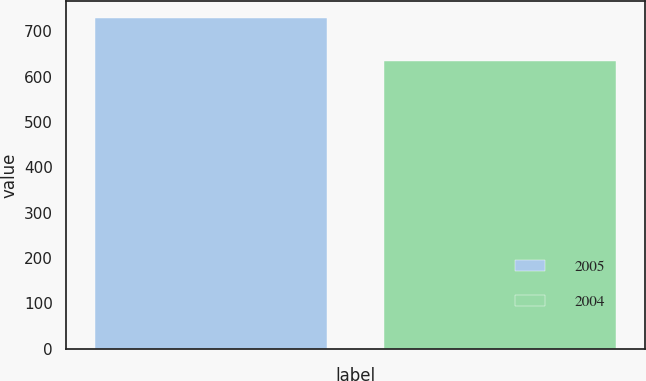<chart> <loc_0><loc_0><loc_500><loc_500><bar_chart><fcel>2005<fcel>2004<nl><fcel>730<fcel>635.1<nl></chart> 